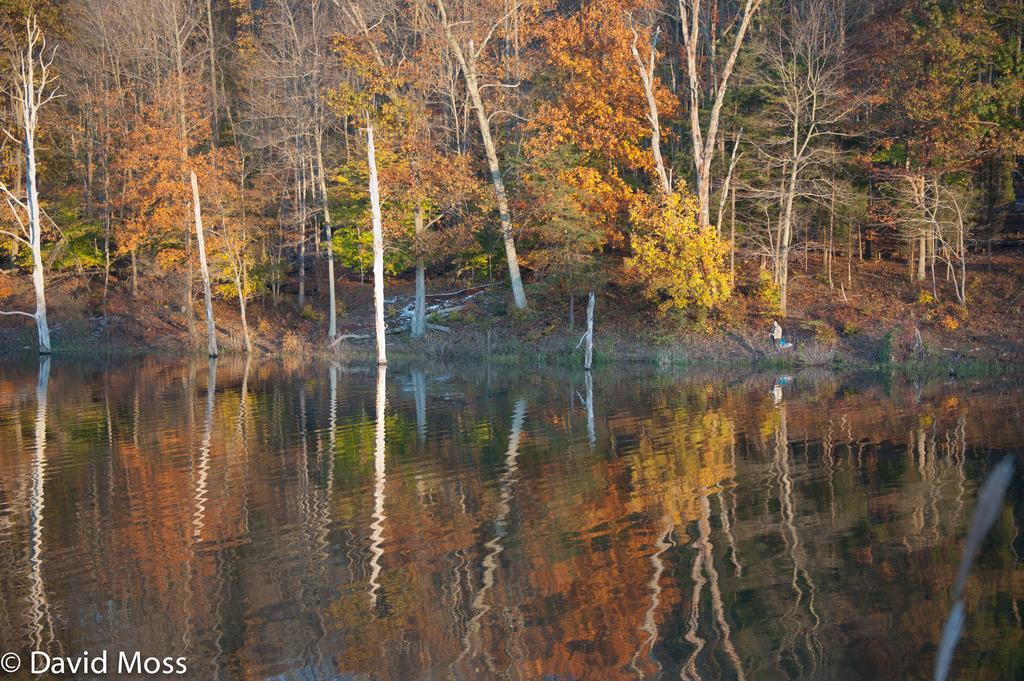Can you describe this image briefly? On the bottom left, there is a watermark. At the bottom of this image, there is water. In the background, there are trees, plants, a person and grass on the ground. 